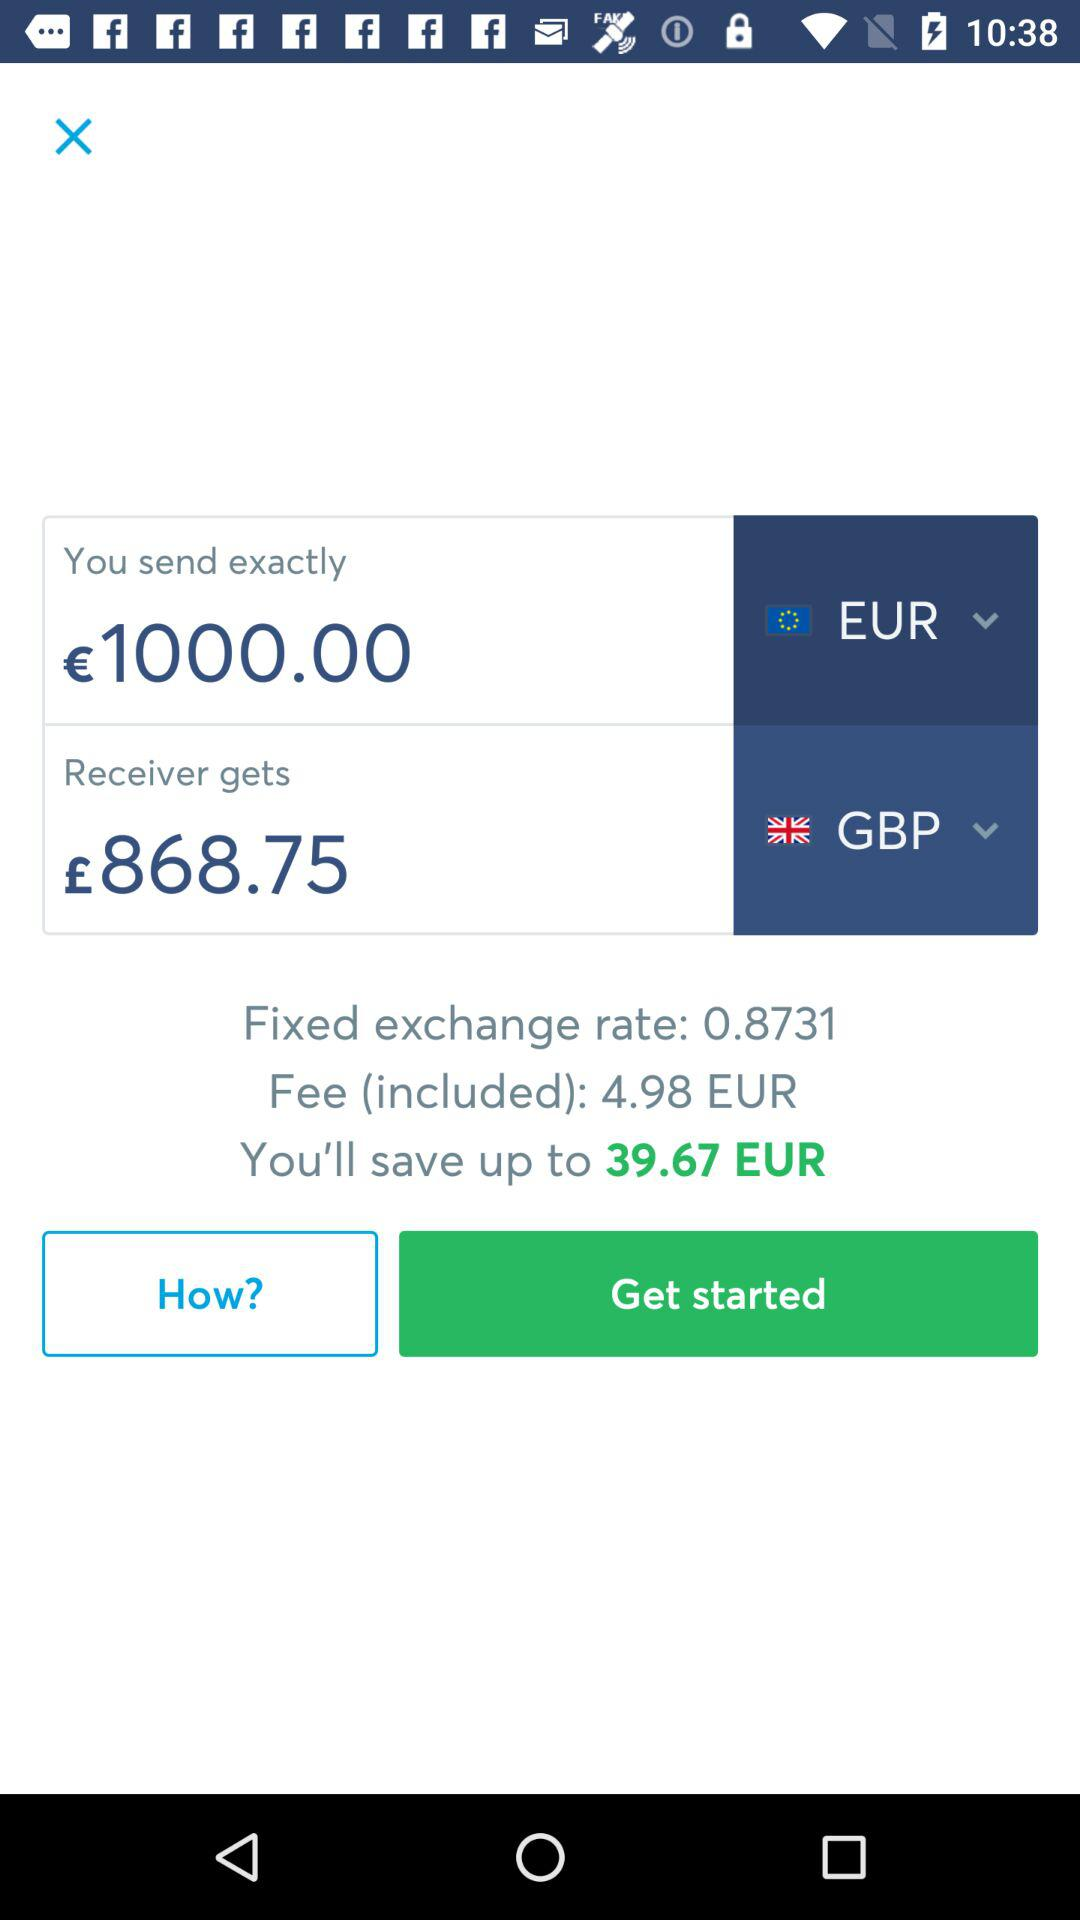How much money can we save? You can save up to 39.67 EUR. 